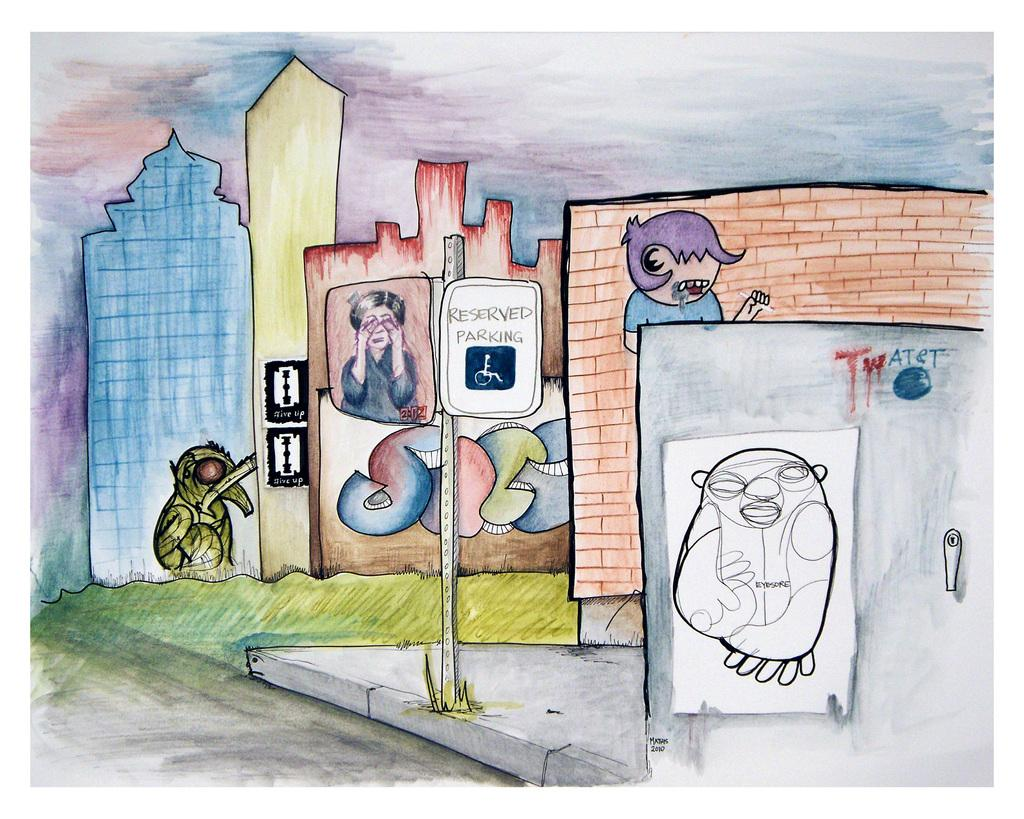What type of artwork is depicted in the image? The image is a painting. What is the main object in the painting? There is a board in the painting. Are there any human figures in the painting? Yes, there are people in the painting. What type of structures are present in the painting? There are walls in the painting. What can be seen on the right side of the painting? There is a drawing sketch on the right side of the painting. Is there any text or writing in the painting? Yes, there is something written in the painting. Can you tell me how many monkeys are sitting on the tub in the painting? There are no monkeys or tubs present in the painting; it features a board, people, walls, a drawing sketch, and written text. 